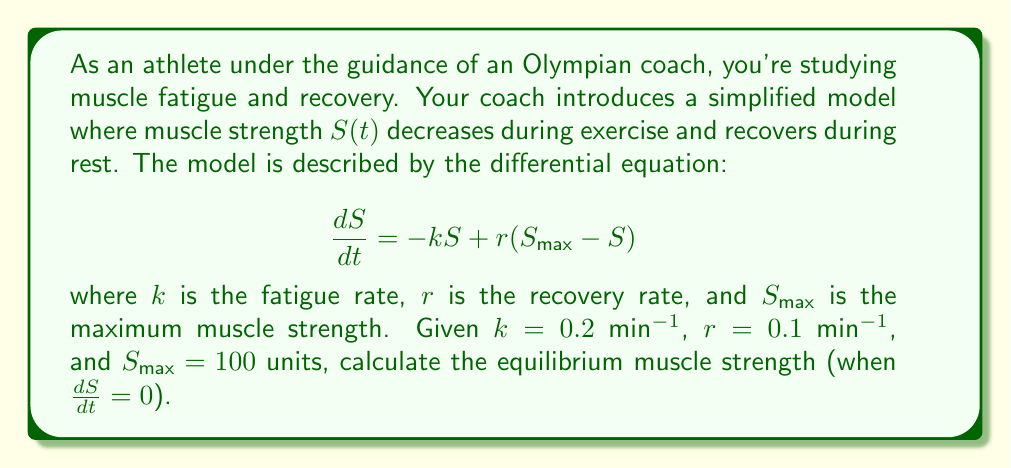Give your solution to this math problem. To solve this problem, we'll follow these steps:

1) The equilibrium muscle strength occurs when there's no change in strength over time, i.e., when $\frac{dS}{dt} = 0$. Let's call this equilibrium strength $S_e$.

2) Set the differential equation equal to zero:

   $$0 = -kS_e + r(S_{\text{max}} - S_e)$$

3) Substitute the given values:

   $$0 = -0.2S_e + 0.1(100 - S_e)$$

4) Expand the brackets:

   $$0 = -0.2S_e + 10 - 0.1S_e$$

5) Combine like terms:

   $$0 = -0.3S_e + 10$$

6) Add $0.3S_e$ to both sides:

   $$0.3S_e = 10$$

7) Divide both sides by 0.3:

   $$S_e = \frac{10}{0.3} \approx 33.33$$

Therefore, the equilibrium muscle strength is approximately 33.33 units.
Answer: $S_e \approx 33.33$ units 